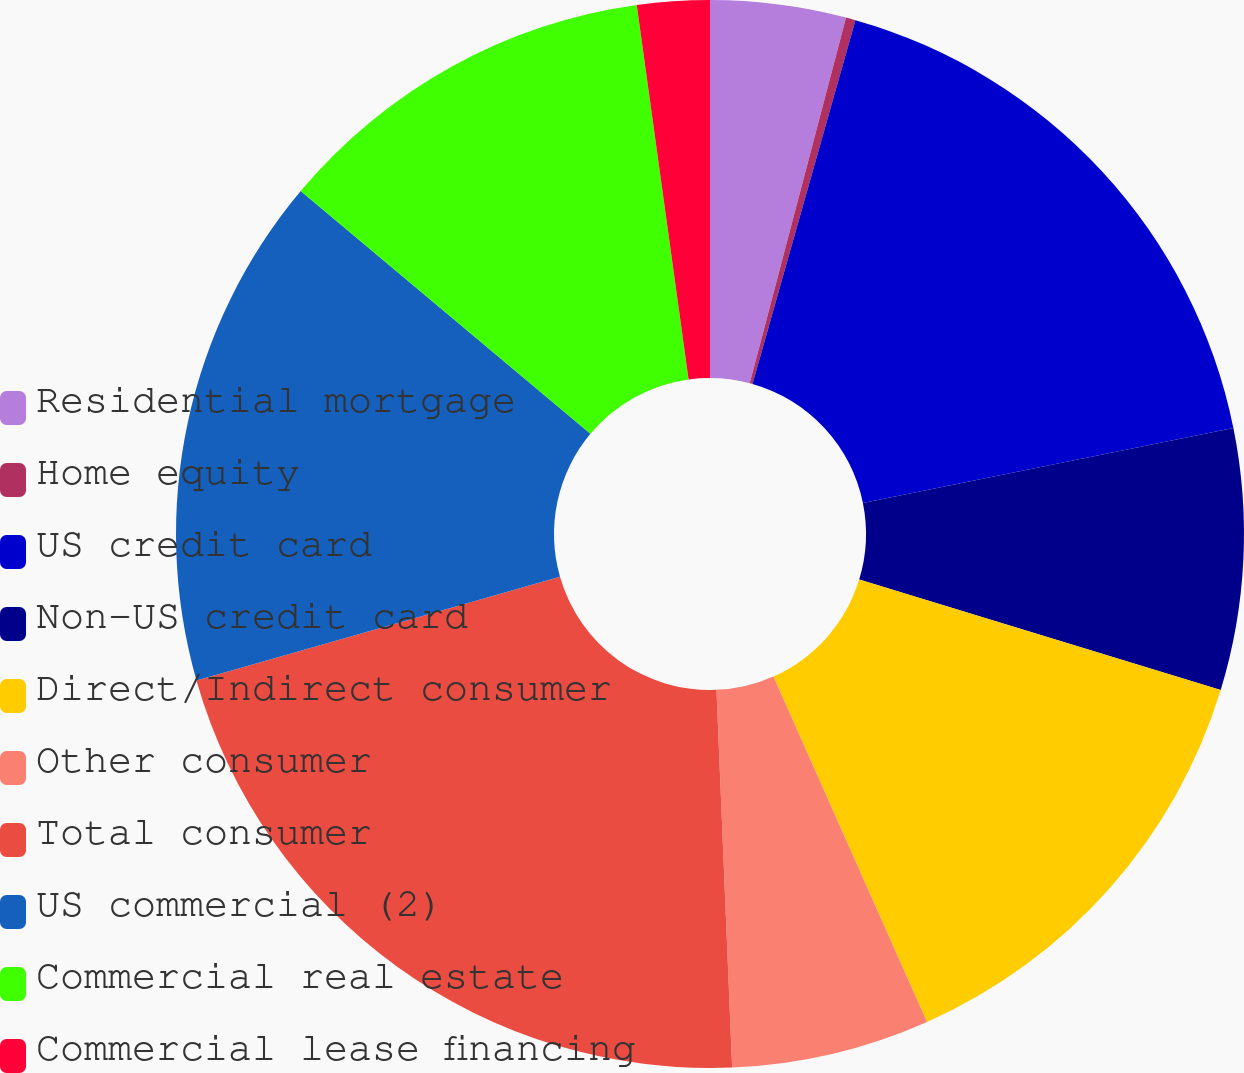<chart> <loc_0><loc_0><loc_500><loc_500><pie_chart><fcel>Residential mortgage<fcel>Home equity<fcel>US credit card<fcel>Non-US credit card<fcel>Direct/Indirect consumer<fcel>Other consumer<fcel>Total consumer<fcel>US commercial (2)<fcel>Commercial real estate<fcel>Commercial lease financing<nl><fcel>4.1%<fcel>0.29%<fcel>17.43%<fcel>7.9%<fcel>13.62%<fcel>6.0%<fcel>21.24%<fcel>15.52%<fcel>11.71%<fcel>2.19%<nl></chart> 